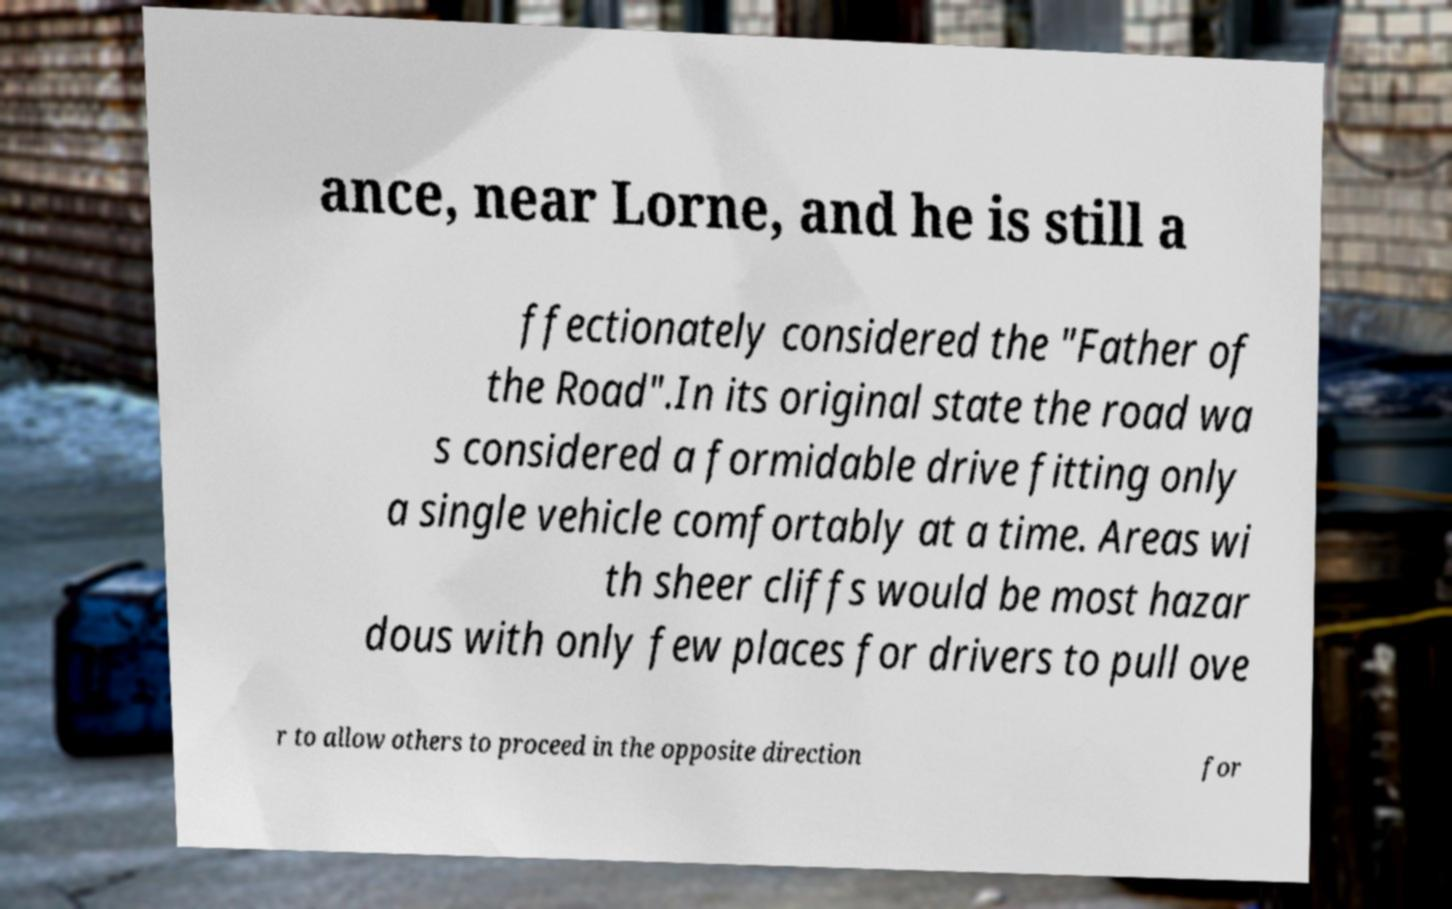I need the written content from this picture converted into text. Can you do that? ance, near Lorne, and he is still a ffectionately considered the "Father of the Road".In its original state the road wa s considered a formidable drive fitting only a single vehicle comfortably at a time. Areas wi th sheer cliffs would be most hazar dous with only few places for drivers to pull ove r to allow others to proceed in the opposite direction for 